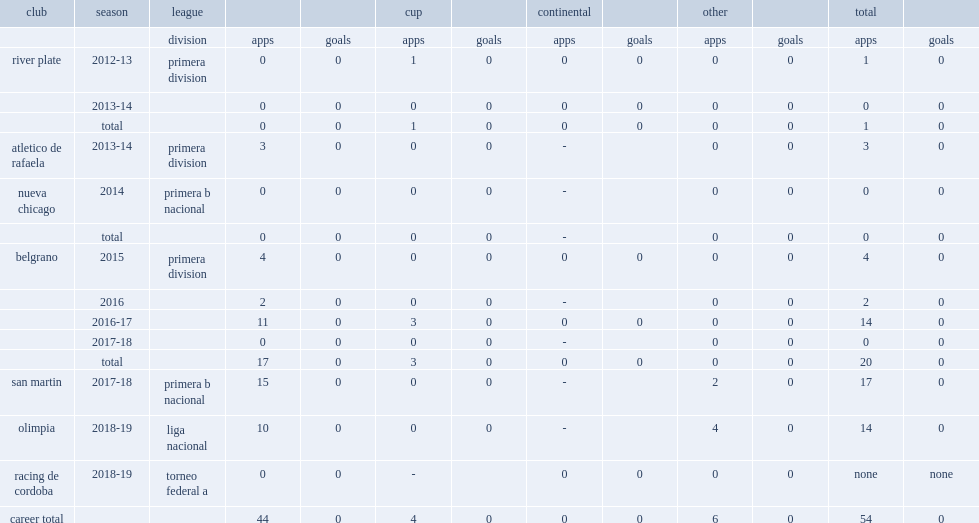Write the full table. {'header': ['club', 'season', 'league', '', '', 'cup', '', 'continental', '', 'other', '', 'total', ''], 'rows': [['', '', 'division', 'apps', 'goals', 'apps', 'goals', 'apps', 'goals', 'apps', 'goals', 'apps', 'goals'], ['river plate', '2012-13', 'primera division', '0', '0', '1', '0', '0', '0', '0', '0', '1', '0'], ['', '2013-14', '', '0', '0', '0', '0', '0', '0', '0', '0', '0', '0'], ['', 'total', '', '0', '0', '1', '0', '0', '0', '0', '0', '1', '0'], ['atletico de rafaela', '2013-14', 'primera division', '3', '0', '0', '0', '-', '', '0', '0', '3', '0'], ['nueva chicago', '2014', 'primera b nacional', '0', '0', '0', '0', '-', '', '0', '0', '0', '0'], ['', 'total', '', '0', '0', '0', '0', '-', '', '0', '0', '0', '0'], ['belgrano', '2015', 'primera division', '4', '0', '0', '0', '0', '0', '0', '0', '4', '0'], ['', '2016', '', '2', '0', '0', '0', '-', '', '0', '0', '2', '0'], ['', '2016-17', '', '11', '0', '3', '0', '0', '0', '0', '0', '14', '0'], ['', '2017-18', '', '0', '0', '0', '0', '-', '', '0', '0', '0', '0'], ['', 'total', '', '17', '0', '3', '0', '0', '0', '0', '0', '20', '0'], ['san martin', '2017-18', 'primera b nacional', '15', '0', '0', '0', '-', '', '2', '0', '17', '0'], ['olimpia', '2018-19', 'liga nacional', '10', '0', '0', '0', '-', '', '4', '0', '14', '0'], ['racing de cordoba', '2018-19', 'torneo federal a', '0', '0', '-', '', '0', '0', '0', '0', 'none', 'none'], ['career total', '', '', '44', '0', '4', '0', '0', '0', '6', '0', '54', '0']]} Which club did espindola play for in 2012-13? River plate. 